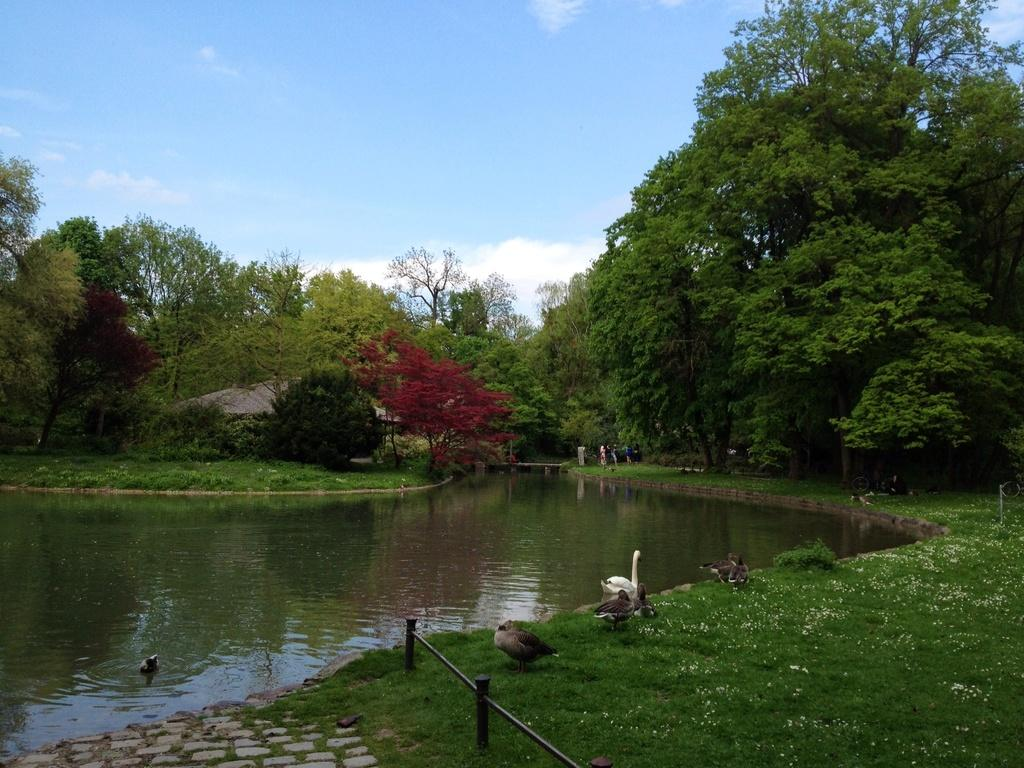What type of animals are at the bottom of the image? There are birds at the bottom of the image. What is located on the left side of the image? There is water on the left side of the image. What can be seen in the background of the image? There are trees in the background of the image. What is visible at the top of the image? The sky is visible at the top of the image. What type of toy is being used by the birds in the image? There is no toy present in the image; it features birds near water with trees in the background. Can you describe the flesh of the birds in the image? There is no need to describe the flesh of the birds in the image, as the focus is on their presence and location, not their physical characteristics. 